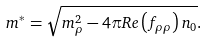<formula> <loc_0><loc_0><loc_500><loc_500>m ^ { * } = \sqrt { m _ { \rho } ^ { 2 } - 4 \pi R e \left ( f _ { \rho \rho } \right ) n _ { 0 } } .</formula> 